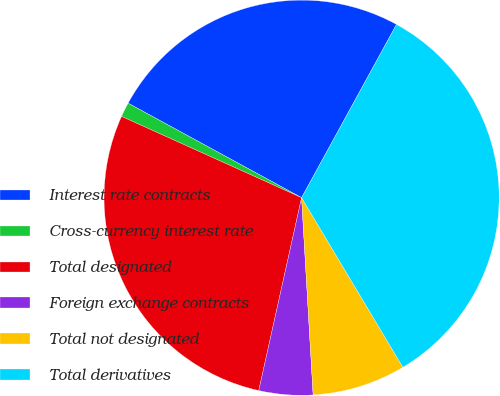Convert chart. <chart><loc_0><loc_0><loc_500><loc_500><pie_chart><fcel>Interest rate contracts<fcel>Cross-currency interest rate<fcel>Total designated<fcel>Foreign exchange contracts<fcel>Total not designated<fcel>Total derivatives<nl><fcel>25.04%<fcel>1.19%<fcel>28.27%<fcel>4.41%<fcel>7.64%<fcel>33.45%<nl></chart> 